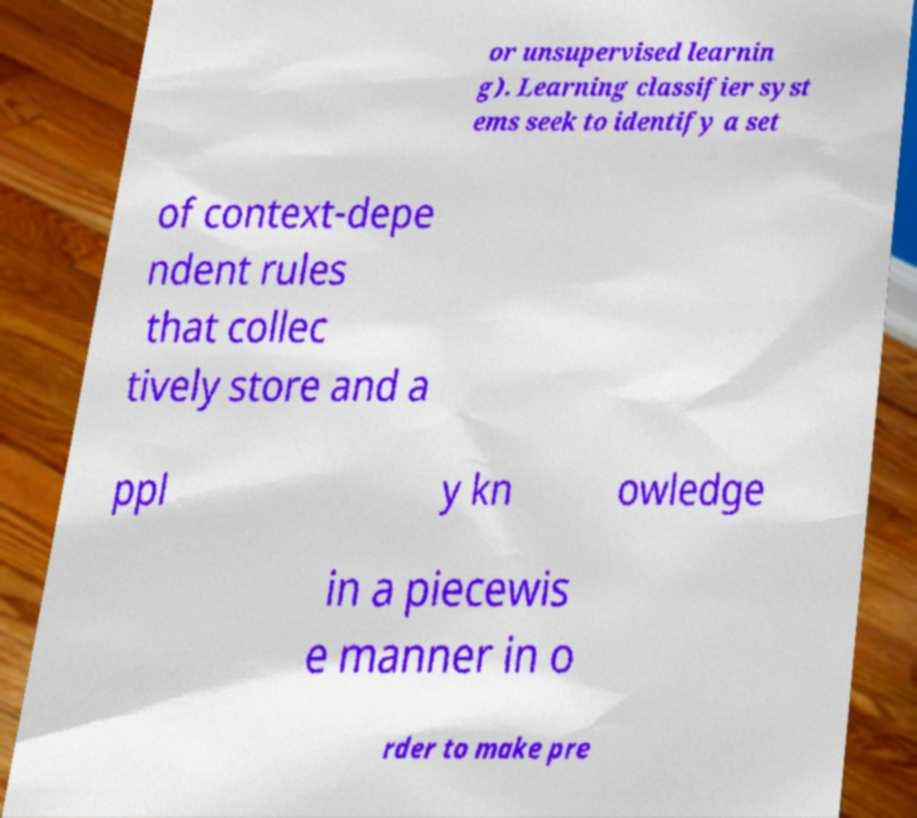There's text embedded in this image that I need extracted. Can you transcribe it verbatim? or unsupervised learnin g). Learning classifier syst ems seek to identify a set of context-depe ndent rules that collec tively store and a ppl y kn owledge in a piecewis e manner in o rder to make pre 